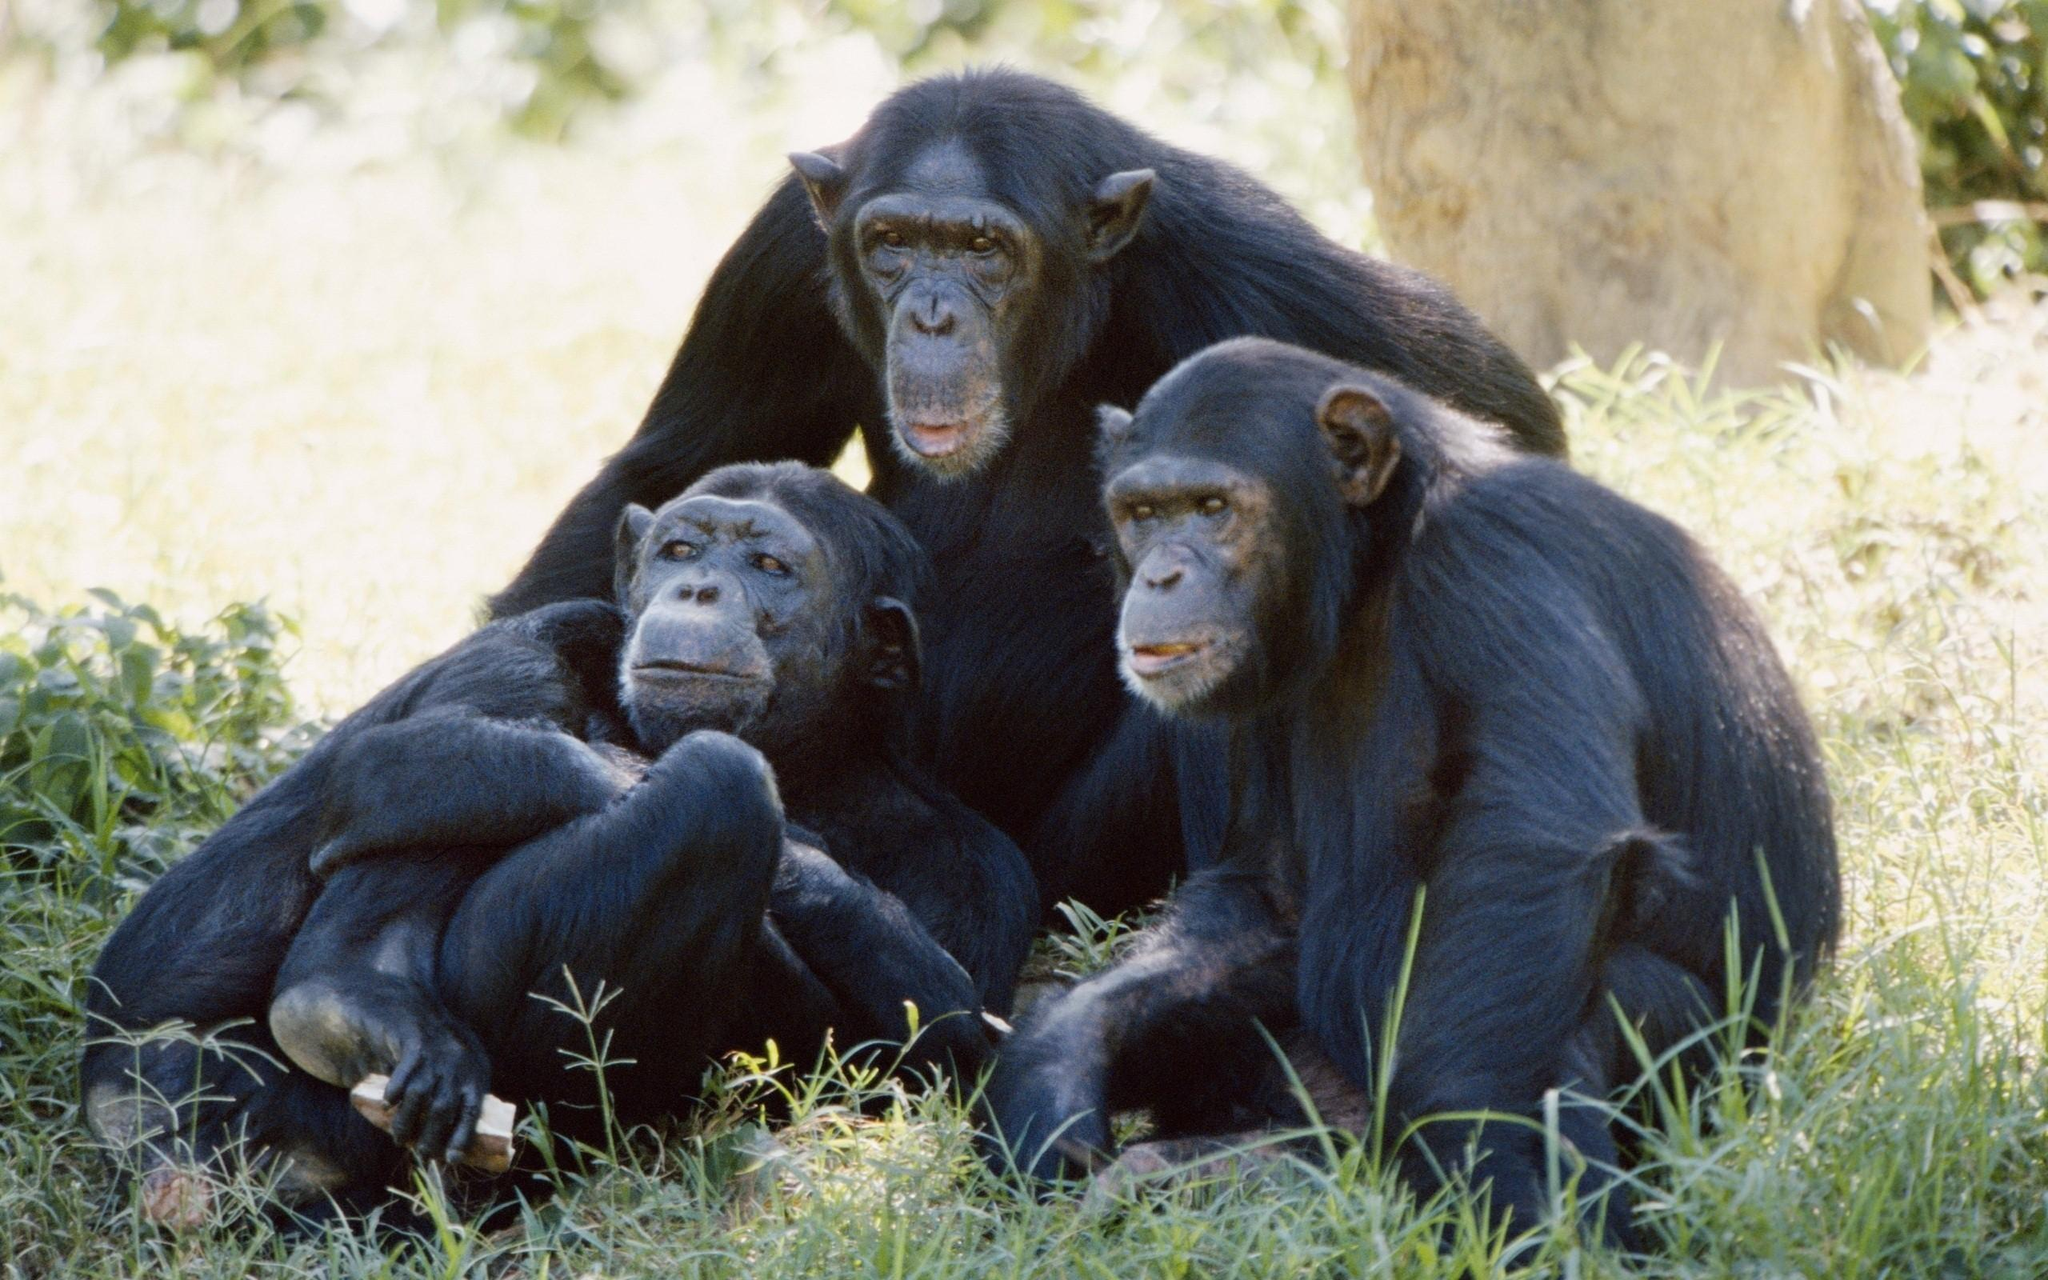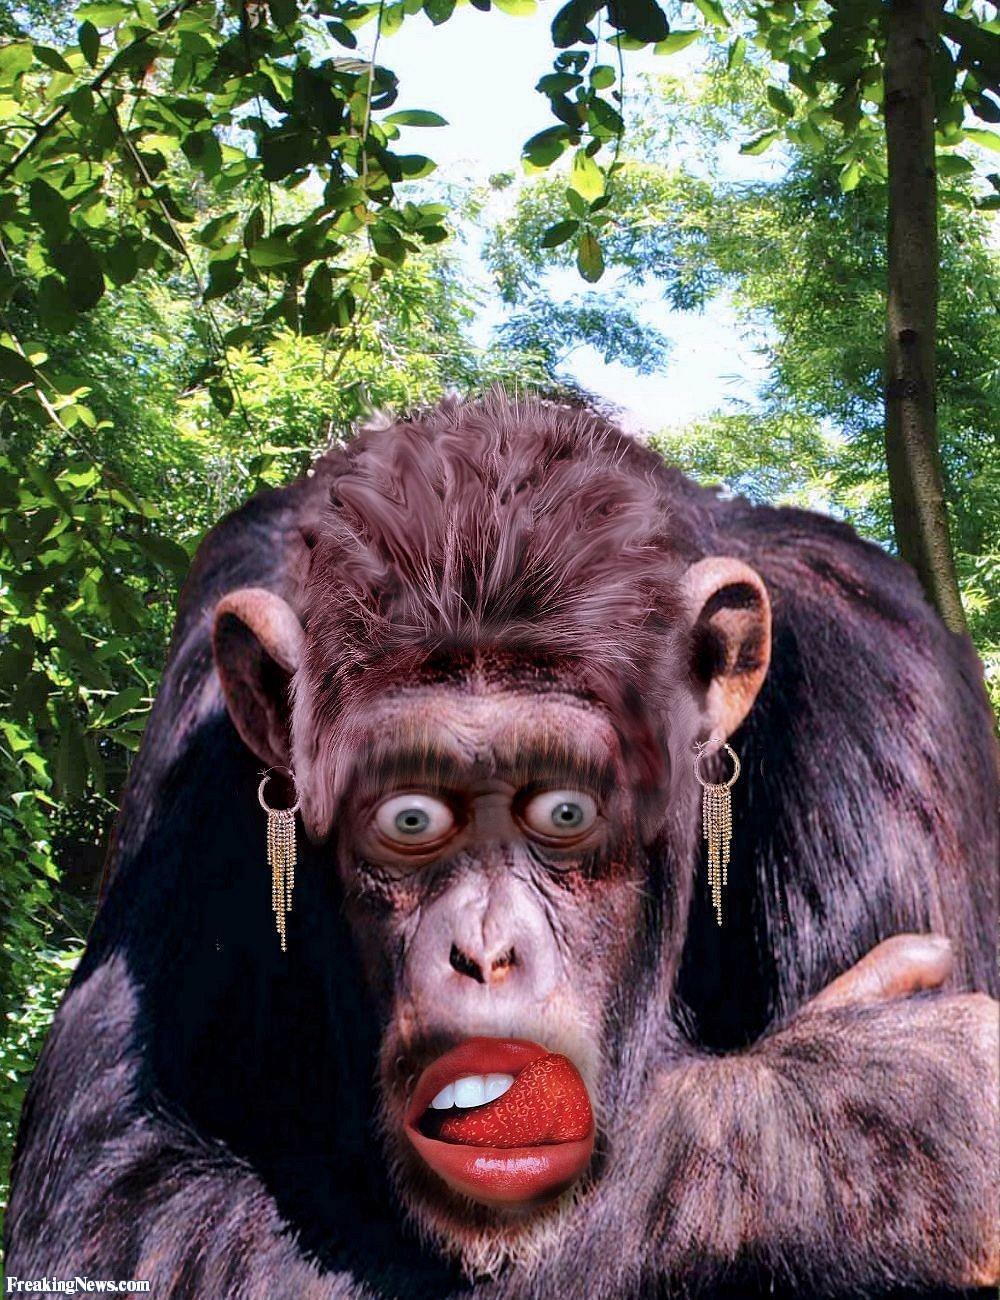The first image is the image on the left, the second image is the image on the right. For the images shown, is this caption "There are only two monkeys." true? Answer yes or no. No. The first image is the image on the left, the second image is the image on the right. Given the left and right images, does the statement "One of the image features more than one monkey." hold true? Answer yes or no. Yes. 